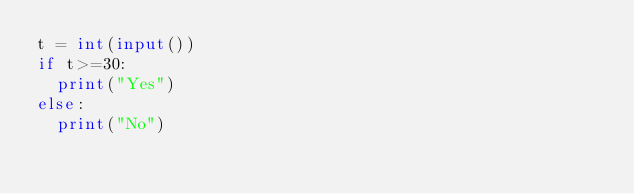<code> <loc_0><loc_0><loc_500><loc_500><_Python_>t = int(input())
if t>=30:
  print("Yes")
else:
  print("No")</code> 